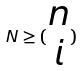<formula> <loc_0><loc_0><loc_500><loc_500>N \geq ( \begin{matrix} n \\ i \end{matrix} )</formula> 